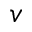Convert formula to latex. <formula><loc_0><loc_0><loc_500><loc_500>v</formula> 